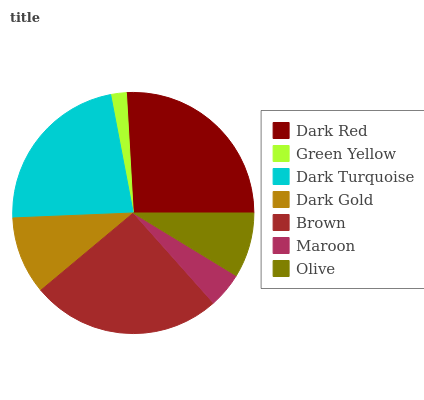Is Green Yellow the minimum?
Answer yes or no. Yes. Is Dark Red the maximum?
Answer yes or no. Yes. Is Dark Turquoise the minimum?
Answer yes or no. No. Is Dark Turquoise the maximum?
Answer yes or no. No. Is Dark Turquoise greater than Green Yellow?
Answer yes or no. Yes. Is Green Yellow less than Dark Turquoise?
Answer yes or no. Yes. Is Green Yellow greater than Dark Turquoise?
Answer yes or no. No. Is Dark Turquoise less than Green Yellow?
Answer yes or no. No. Is Dark Gold the high median?
Answer yes or no. Yes. Is Dark Gold the low median?
Answer yes or no. Yes. Is Maroon the high median?
Answer yes or no. No. Is Dark Turquoise the low median?
Answer yes or no. No. 